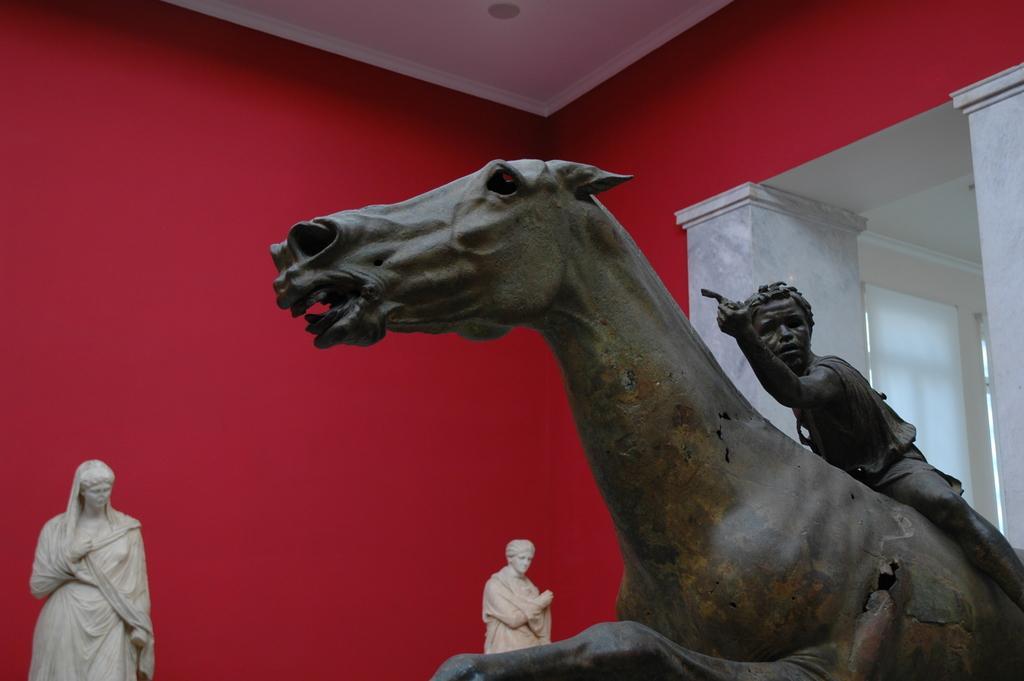In one or two sentences, can you explain what this image depicts? In this image I can see few statues, they are in brown and cream color. Background the wall is in red and white color. 